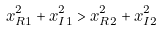Convert formula to latex. <formula><loc_0><loc_0><loc_500><loc_500>x _ { R 1 } ^ { 2 } + x _ { I 1 } ^ { 2 } > x _ { R 2 } ^ { 2 } + x _ { I 2 } ^ { 2 }</formula> 